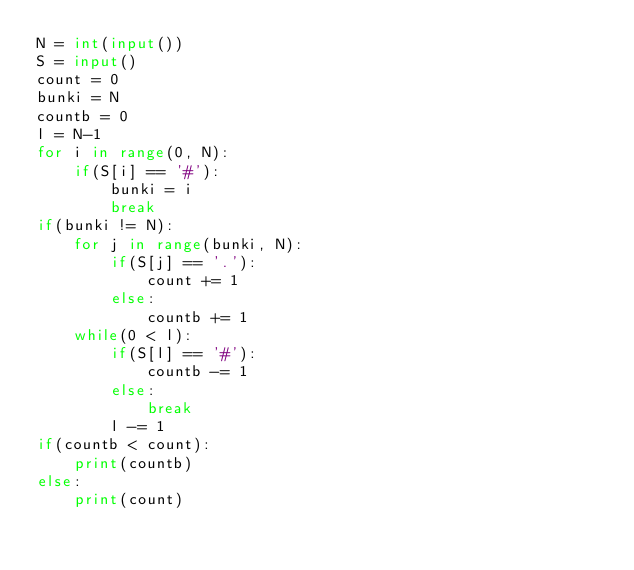<code> <loc_0><loc_0><loc_500><loc_500><_Python_>N = int(input())
S = input()
count = 0
bunki = N
countb = 0
l = N-1
for i in range(0, N):
	if(S[i] == '#'):
		bunki = i
		break
if(bunki != N):
	for j in range(bunki, N):
		if(S[j] == '.'):
			count += 1
		else:
			countb += 1 
	while(0 < l):
		if(S[l] == '#'):
			countb -= 1
		else:
			break
		l -= 1
if(countb < count):
	print(countb)
else:
	print(count)</code> 